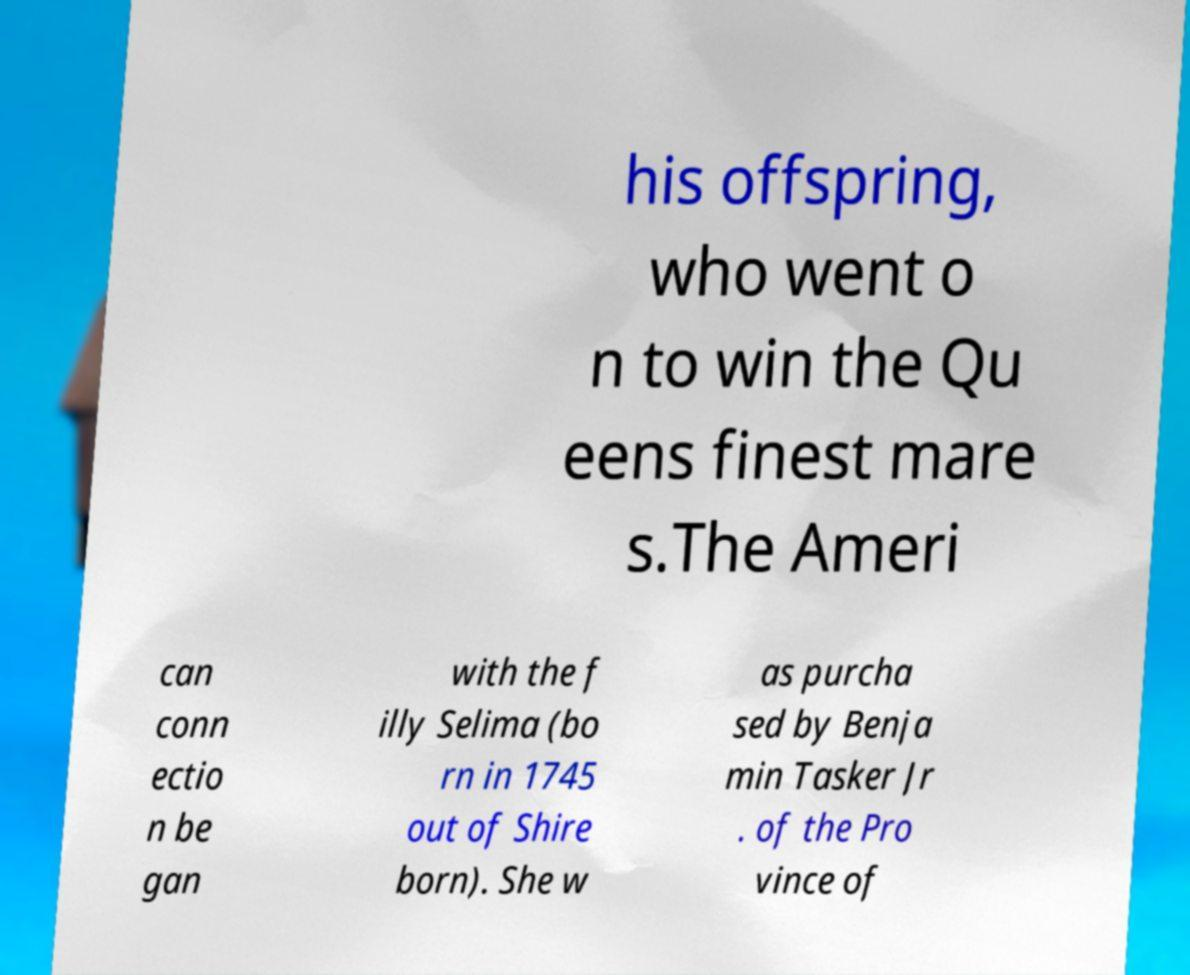Please identify and transcribe the text found in this image. his offspring, who went o n to win the Qu eens finest mare s.The Ameri can conn ectio n be gan with the f illy Selima (bo rn in 1745 out of Shire born). She w as purcha sed by Benja min Tasker Jr . of the Pro vince of 